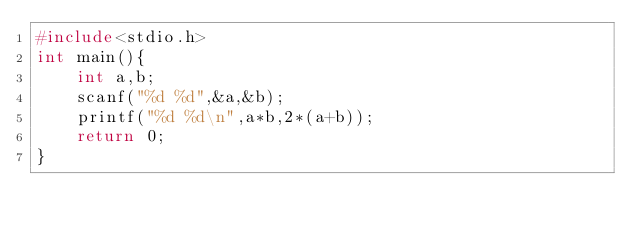<code> <loc_0><loc_0><loc_500><loc_500><_C_>#include<stdio.h>
int main(){
    int a,b;
    scanf("%d %d",&a,&b);
    printf("%d %d\n",a*b,2*(a+b));
    return 0;
}</code> 